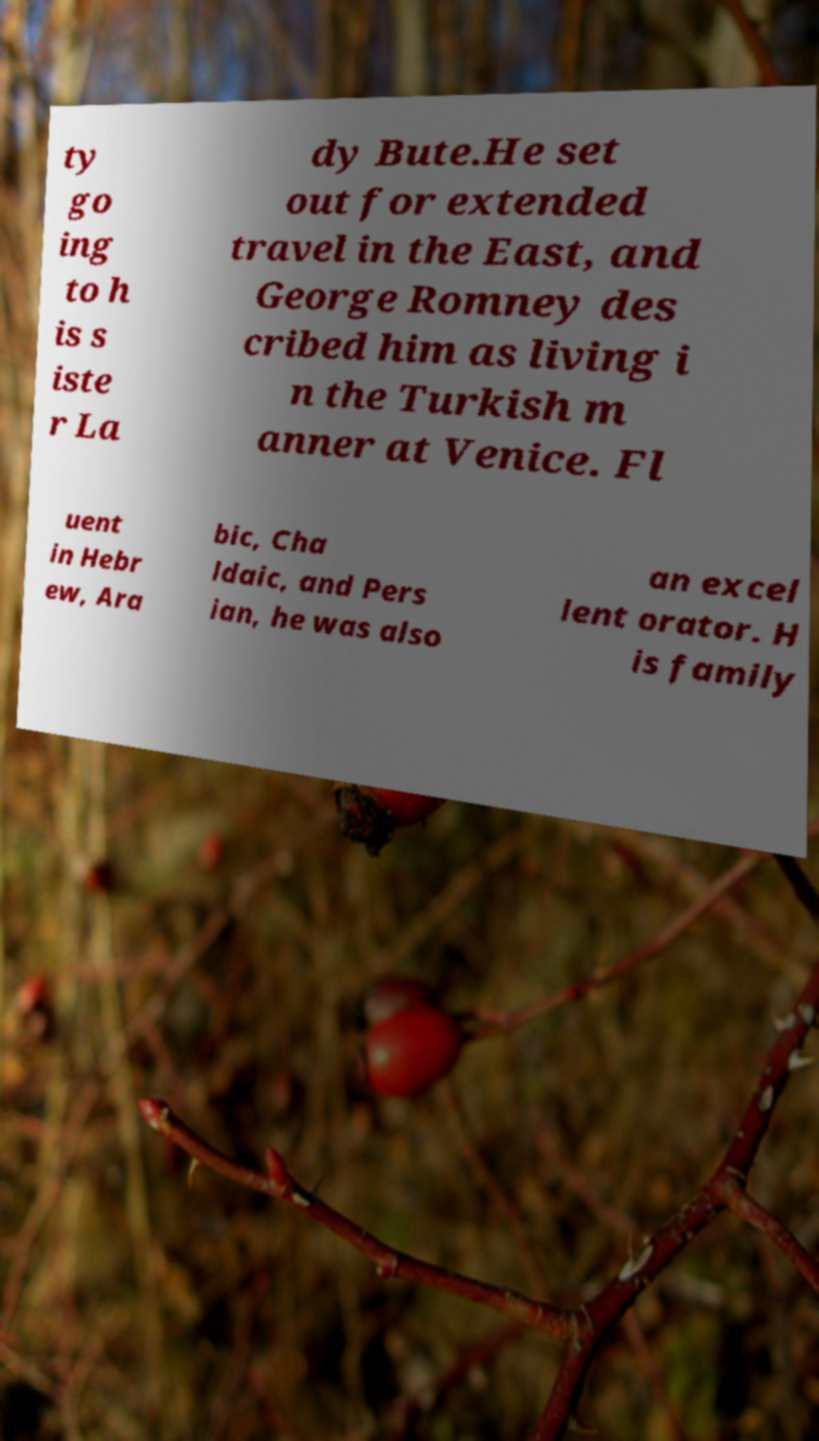For documentation purposes, I need the text within this image transcribed. Could you provide that? ty go ing to h is s iste r La dy Bute.He set out for extended travel in the East, and George Romney des cribed him as living i n the Turkish m anner at Venice. Fl uent in Hebr ew, Ara bic, Cha ldaic, and Pers ian, he was also an excel lent orator. H is family 